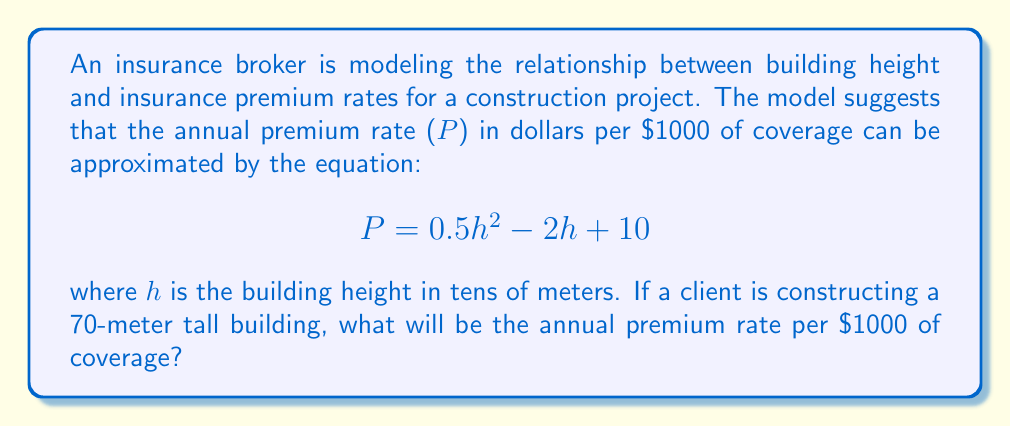What is the answer to this math problem? To solve this problem, we need to follow these steps:

1) First, we need to convert the building height from meters to tens of meters:
   70 meters = 7 tens of meters
   So, h = 7

2) Now, we can substitute h = 7 into the given equation:
   $$P = 0.5h^2 - 2h + 10$$

3) Let's calculate each term:
   $$0.5h^2 = 0.5 * 7^2 = 0.5 * 49 = 24.5$$
   $$-2h = -2 * 7 = -14$$
   The constant term is already 10

4) Now, we can add these terms:
   $$P = 24.5 - 14 + 10 = 20.5$$

Therefore, the annual premium rate will be $20.50 per $1000 of coverage.
Answer: $20.50 per $1000 of coverage 